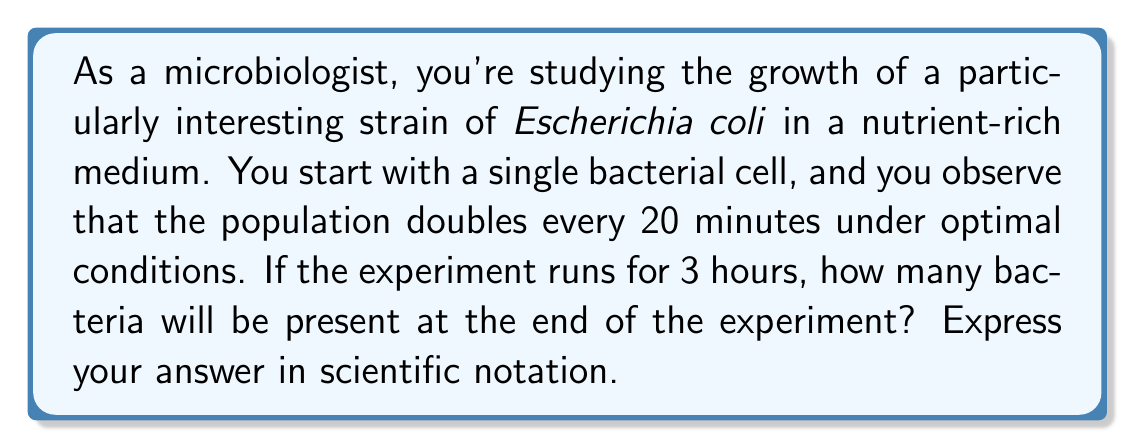Could you help me with this problem? Let's approach this step-by-step:

1) First, we need to determine how many doubling periods occur in 3 hours:
   - 3 hours = 180 minutes
   - Each doubling period is 20 minutes
   - Number of doubling periods = $\frac{180 \text{ minutes}}{20 \text{ minutes/period}} = 9$ periods

2) Now, we can set up our exponential growth function:
   - Initial population: $N_0 = 1$ (we start with a single cell)
   - Growth factor: 2 (the population doubles each period)
   - Number of periods: 9

   The exponential growth function is:
   $$ N = N_0 \cdot 2^t $$
   where $N$ is the final population, $N_0$ is the initial population, and $t$ is the number of doubling periods.

3) Plugging in our values:
   $$ N = 1 \cdot 2^9 $$

4) Calculate:
   $$ N = 2^9 = 512 $$

5) Convert to scientific notation:
   $$ N = 5.12 \times 10^2 $$
Answer: $5.12 \times 10^2$ bacteria 